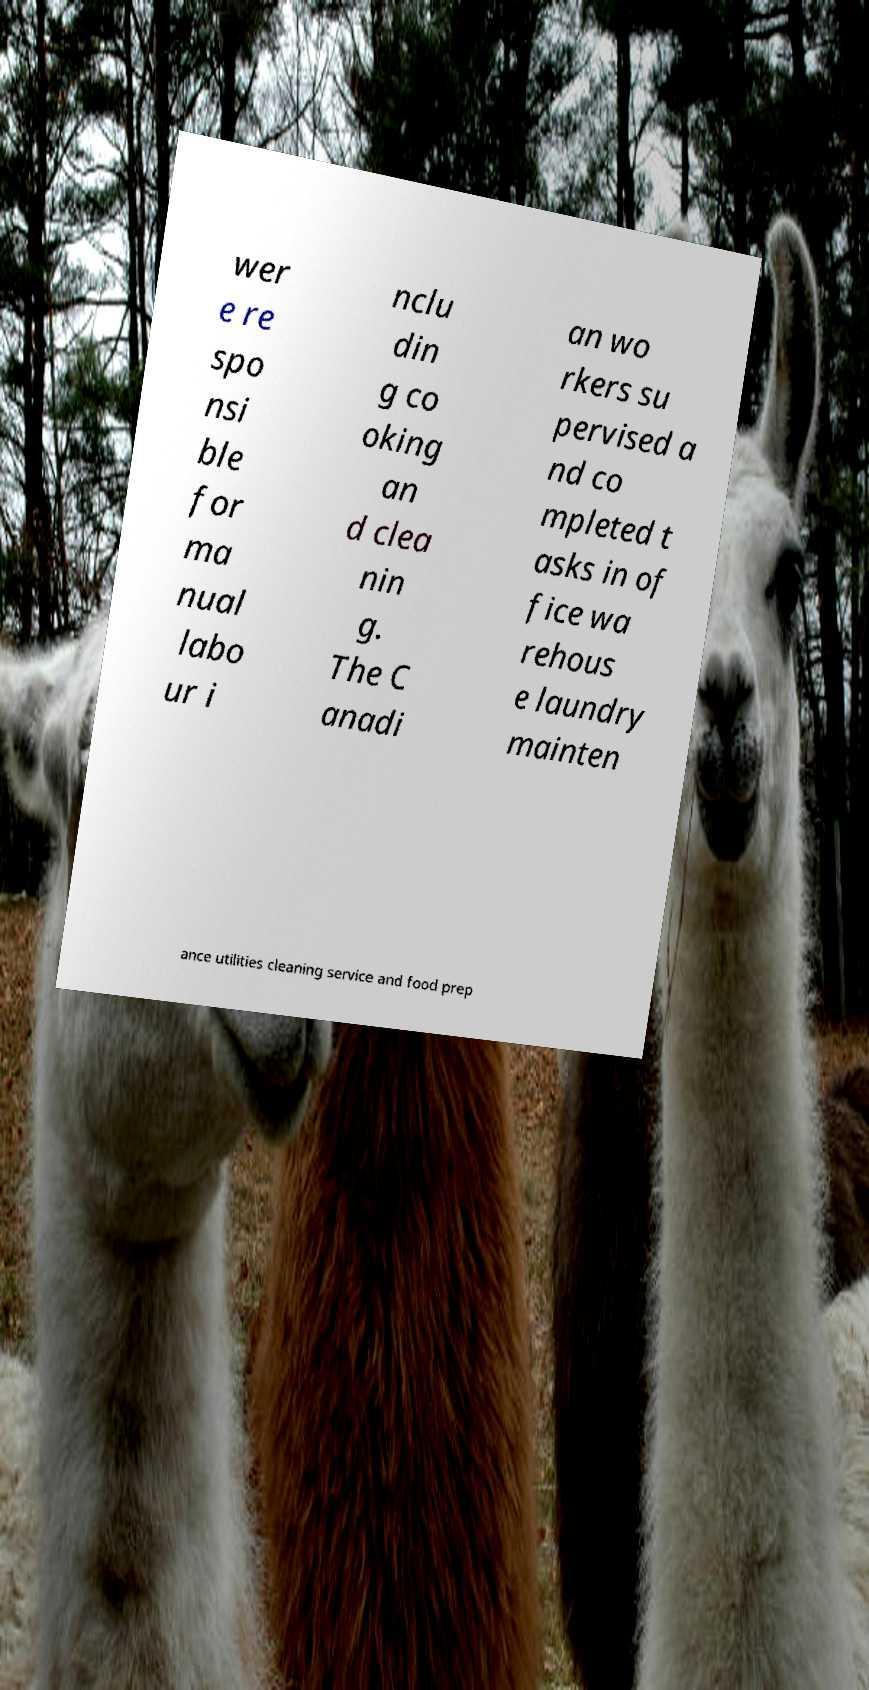What messages or text are displayed in this image? I need them in a readable, typed format. wer e re spo nsi ble for ma nual labo ur i nclu din g co oking an d clea nin g. The C anadi an wo rkers su pervised a nd co mpleted t asks in of fice wa rehous e laundry mainten ance utilities cleaning service and food prep 